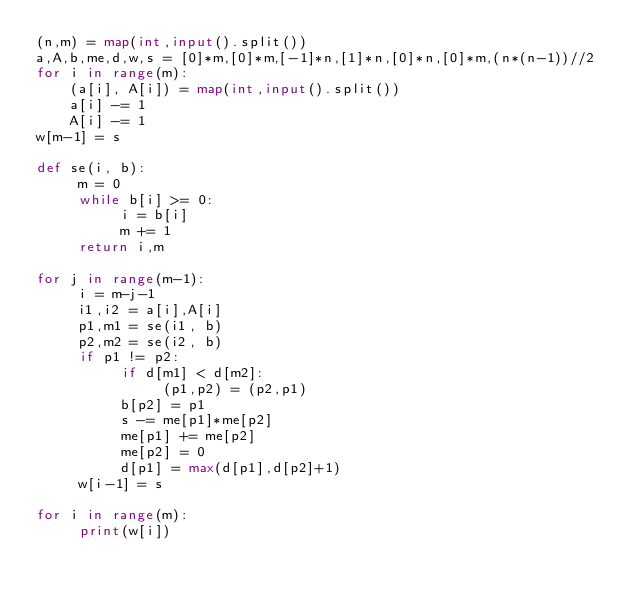<code> <loc_0><loc_0><loc_500><loc_500><_Python_>(n,m) = map(int,input().split())
a,A,b,me,d,w,s = [0]*m,[0]*m,[-1]*n,[1]*n,[0]*n,[0]*m,(n*(n-1))//2
for i in range(m):
    (a[i], A[i]) = map(int,input().split())
    a[i] -= 1
    A[i] -= 1
w[m-1] = s
 
def se(i, b):
     m = 0
     while b[i] >= 0:
          i = b[i]
          m += 1
     return i,m
 
for j in range(m-1):
     i = m-j-1
     i1,i2 = a[i],A[i]
     p1,m1 = se(i1, b)
     p2,m2 = se(i2, b)
     if p1 != p2:
          if d[m1] < d[m2]:
               (p1,p2) = (p2,p1)
          b[p2] = p1
          s -= me[p1]*me[p2]
          me[p1] += me[p2]
          me[p2] = 0
          d[p1] = max(d[p1],d[p2]+1)
     w[i-1] = s
         
for i in range(m):
     print(w[i])</code> 